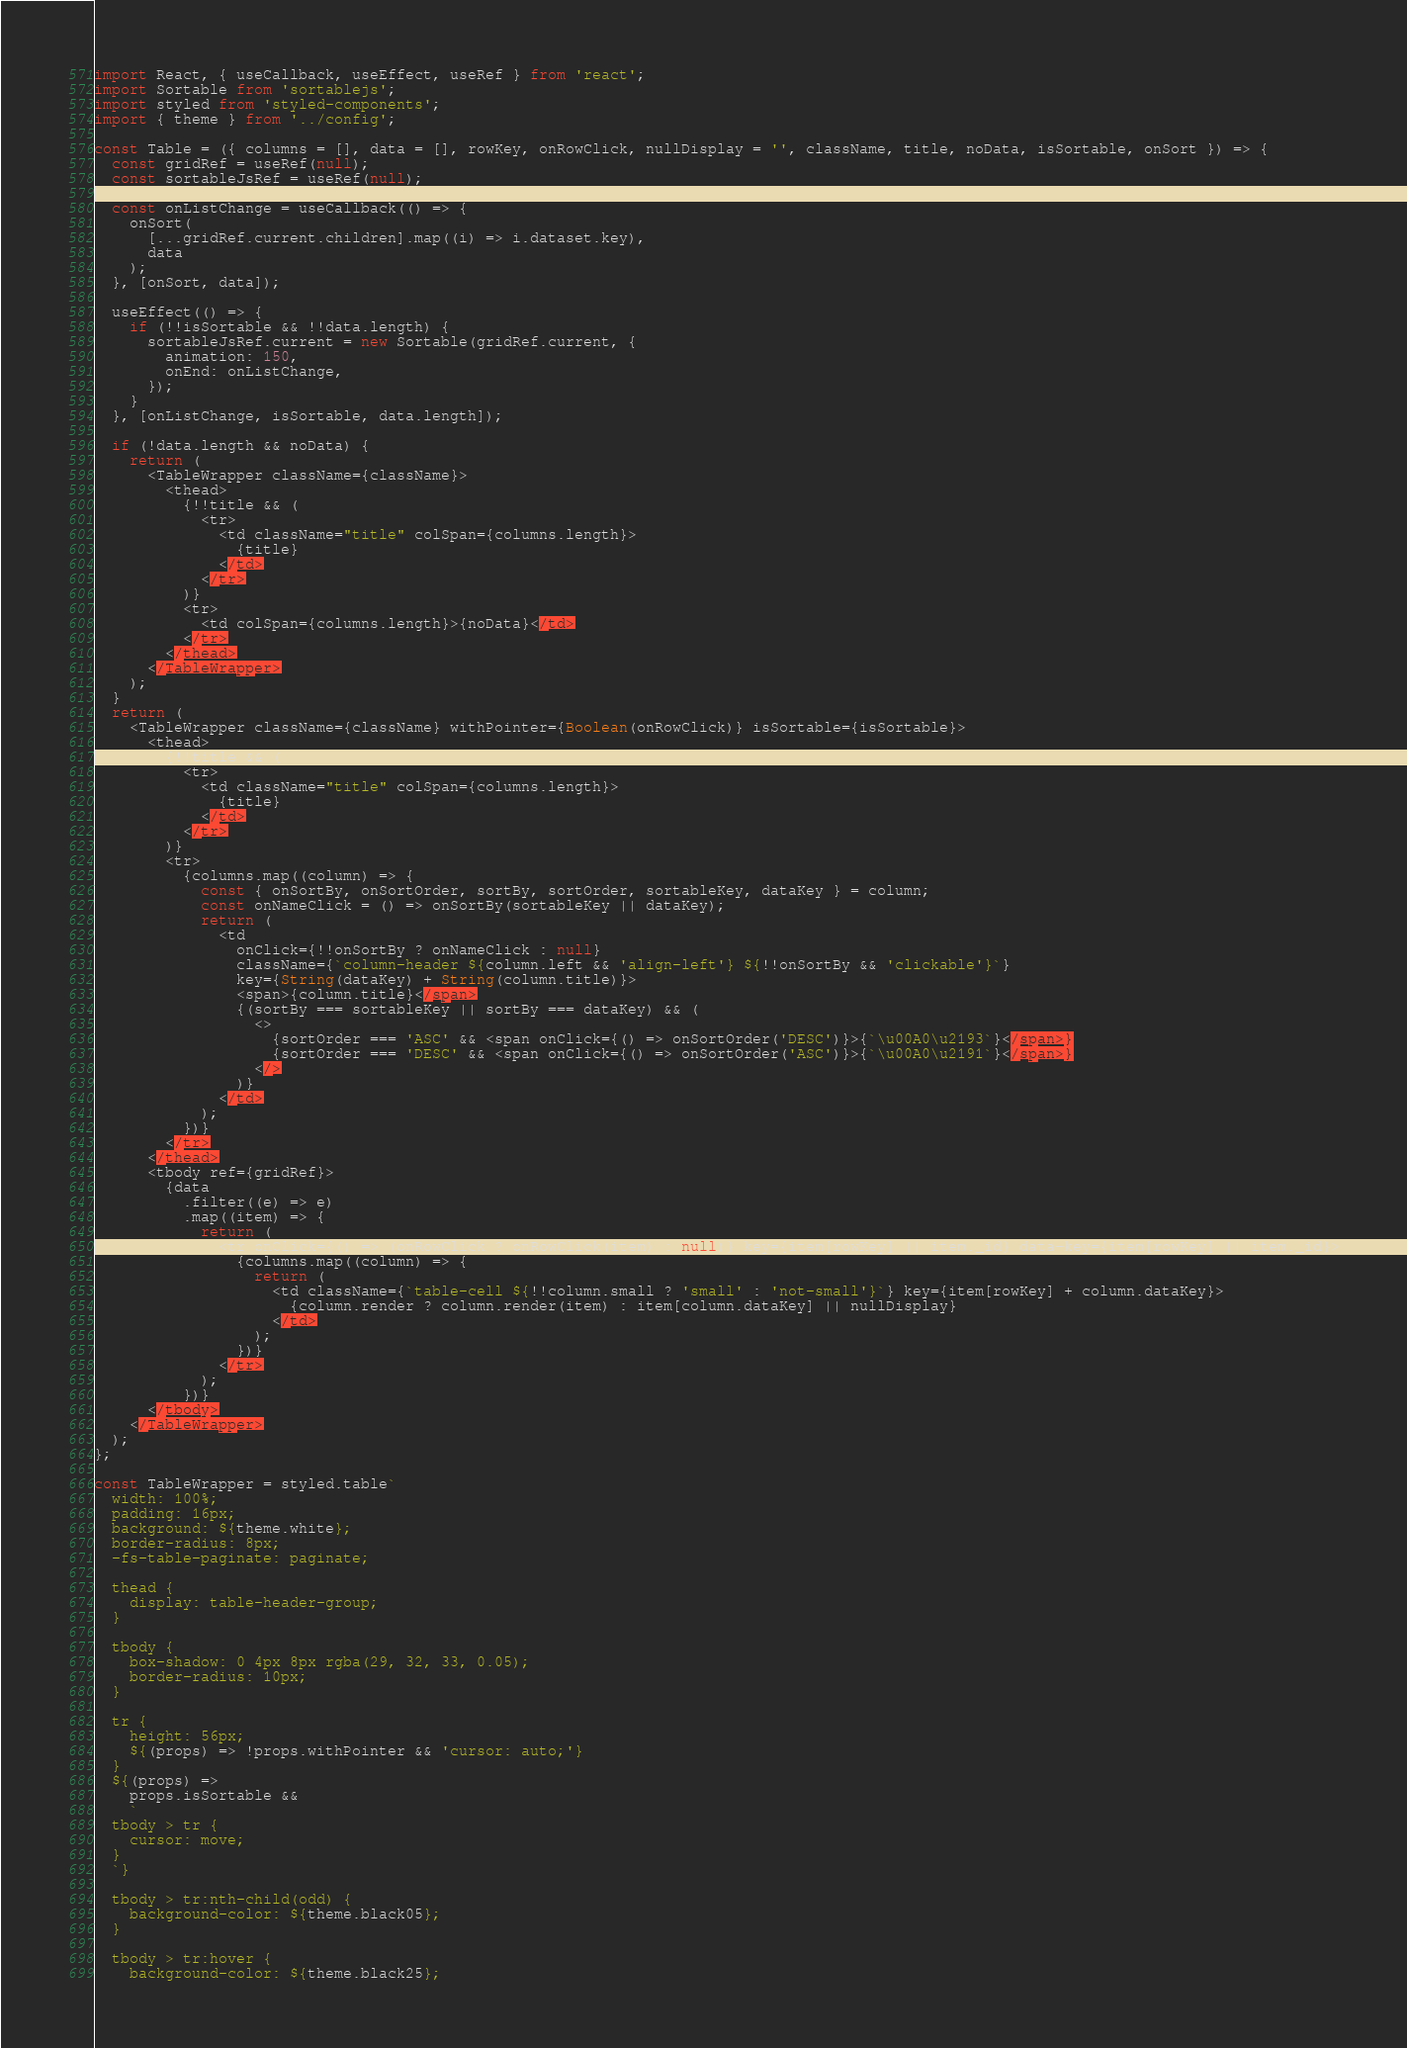Convert code to text. <code><loc_0><loc_0><loc_500><loc_500><_JavaScript_>import React, { useCallback, useEffect, useRef } from 'react';
import Sortable from 'sortablejs';
import styled from 'styled-components';
import { theme } from '../config';

const Table = ({ columns = [], data = [], rowKey, onRowClick, nullDisplay = '', className, title, noData, isSortable, onSort }) => {
  const gridRef = useRef(null);
  const sortableJsRef = useRef(null);

  const onListChange = useCallback(() => {
    onSort(
      [...gridRef.current.children].map((i) => i.dataset.key),
      data
    );
  }, [onSort, data]);

  useEffect(() => {
    if (!!isSortable && !!data.length) {
      sortableJsRef.current = new Sortable(gridRef.current, {
        animation: 150,
        onEnd: onListChange,
      });
    }
  }, [onListChange, isSortable, data.length]);

  if (!data.length && noData) {
    return (
      <TableWrapper className={className}>
        <thead>
          {!!title && (
            <tr>
              <td className="title" colSpan={columns.length}>
                {title}
              </td>
            </tr>
          )}
          <tr>
            <td colSpan={columns.length}>{noData}</td>
          </tr>
        </thead>
      </TableWrapper>
    );
  }
  return (
    <TableWrapper className={className} withPointer={Boolean(onRowClick)} isSortable={isSortable}>
      <thead>
        {!!title && (
          <tr>
            <td className="title" colSpan={columns.length}>
              {title}
            </td>
          </tr>
        )}
        <tr>
          {columns.map((column) => {
            const { onSortBy, onSortOrder, sortBy, sortOrder, sortableKey, dataKey } = column;
            const onNameClick = () => onSortBy(sortableKey || dataKey);
            return (
              <td
                onClick={!!onSortBy ? onNameClick : null}
                className={`column-header ${column.left && 'align-left'} ${!!onSortBy && 'clickable'}`}
                key={String(dataKey) + String(column.title)}>
                <span>{column.title}</span>
                {(sortBy === sortableKey || sortBy === dataKey) && (
                  <>
                    {sortOrder === 'ASC' && <span onClick={() => onSortOrder('DESC')}>{`\u00A0\u2193`}</span>}
                    {sortOrder === 'DESC' && <span onClick={() => onSortOrder('ASC')}>{`\u00A0\u2191`}</span>}
                  </>
                )}
              </td>
            );
          })}
        </tr>
      </thead>
      <tbody ref={gridRef}>
        {data
          .filter((e) => e)
          .map((item) => {
            return (
              <tr onClick={() => (onRowClick ? onRowClick(item) : null)} key={item[rowKey] || item._id} data-key={item[rowKey] || item._id}>
                {columns.map((column) => {
                  return (
                    <td className={`table-cell ${!!column.small ? 'small' : 'not-small'}`} key={item[rowKey] + column.dataKey}>
                      {column.render ? column.render(item) : item[column.dataKey] || nullDisplay}
                    </td>
                  );
                })}
              </tr>
            );
          })}
      </tbody>
    </TableWrapper>
  );
};

const TableWrapper = styled.table`
  width: 100%;
  padding: 16px;
  background: ${theme.white};
  border-radius: 8px;
  -fs-table-paginate: paginate;

  thead {
    display: table-header-group;
  }

  tbody {
    box-shadow: 0 4px 8px rgba(29, 32, 33, 0.05);
    border-radius: 10px;
  }

  tr {
    height: 56px;
    ${(props) => !props.withPointer && 'cursor: auto;'}
  }
  ${(props) =>
    props.isSortable &&
    `
  tbody > tr {
    cursor: move;
  }
  `}

  tbody > tr:nth-child(odd) {
    background-color: ${theme.black05};
  }

  tbody > tr:hover {
    background-color: ${theme.black25};</code> 